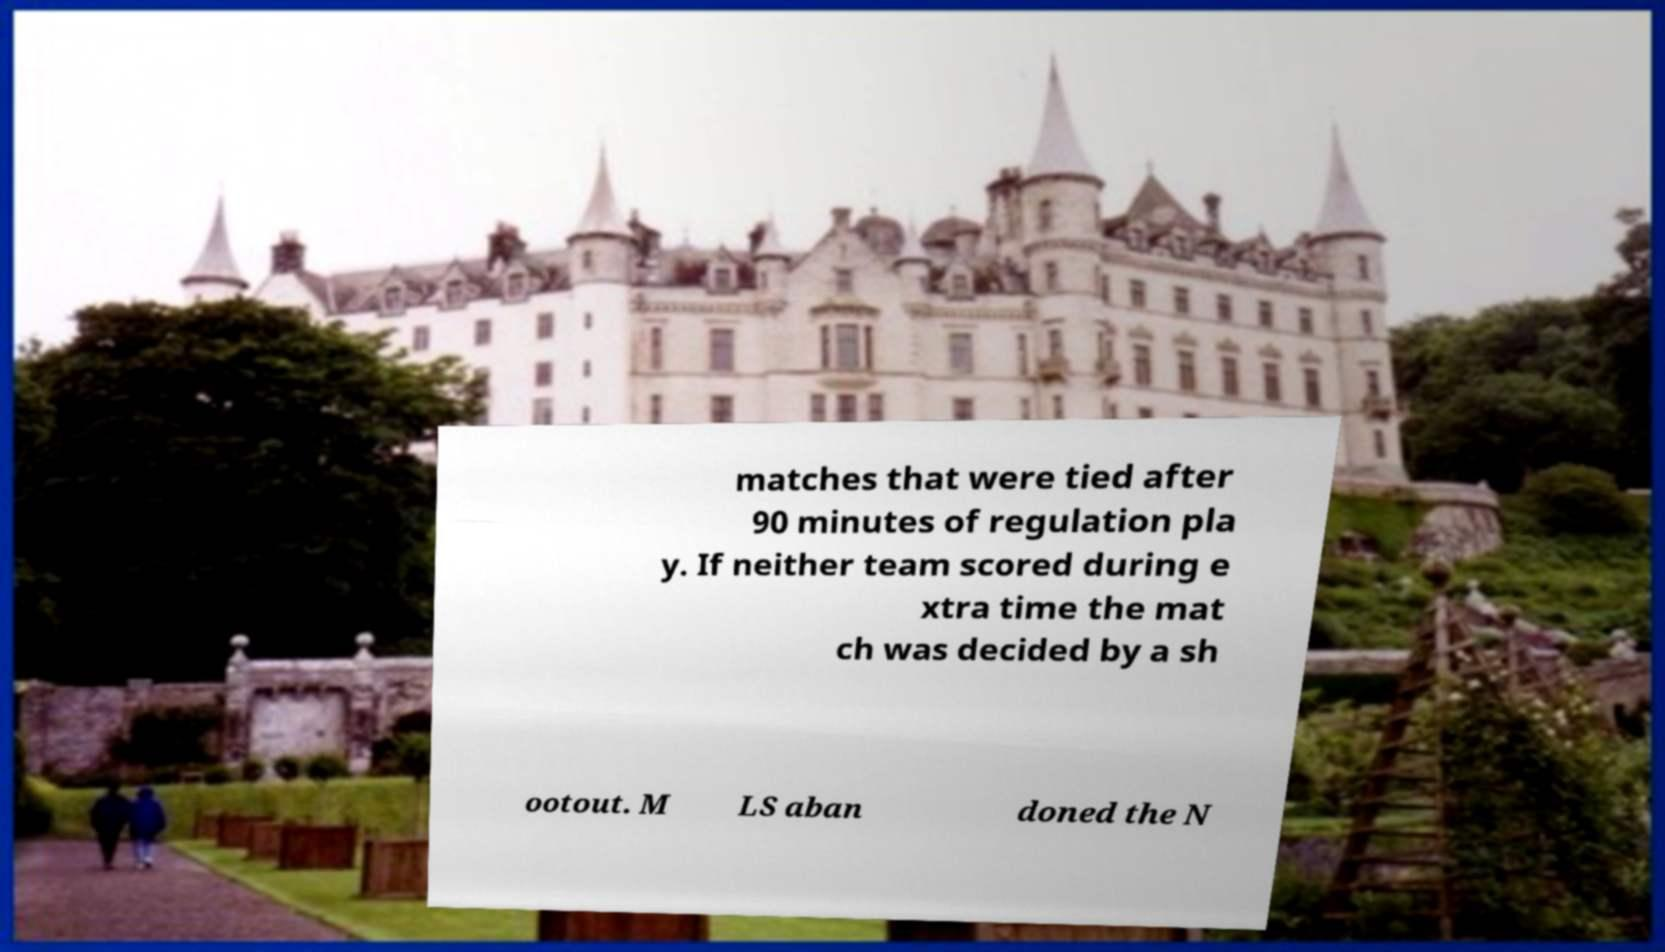Could you assist in decoding the text presented in this image and type it out clearly? matches that were tied after 90 minutes of regulation pla y. If neither team scored during e xtra time the mat ch was decided by a sh ootout. M LS aban doned the N 